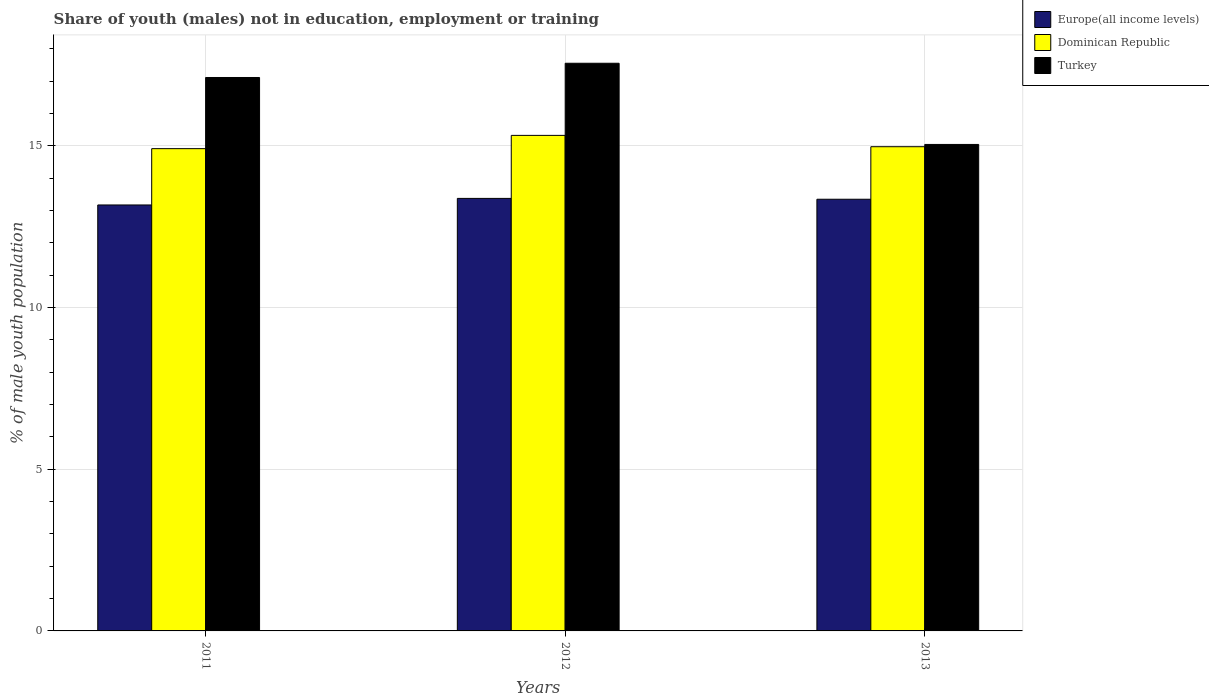Are the number of bars per tick equal to the number of legend labels?
Your answer should be compact. Yes. Are the number of bars on each tick of the X-axis equal?
Keep it short and to the point. Yes. How many bars are there on the 2nd tick from the right?
Offer a very short reply. 3. What is the percentage of unemployed males population in in Turkey in 2011?
Your answer should be compact. 17.11. Across all years, what is the maximum percentage of unemployed males population in in Turkey?
Your response must be concise. 17.55. Across all years, what is the minimum percentage of unemployed males population in in Turkey?
Give a very brief answer. 15.04. What is the total percentage of unemployed males population in in Turkey in the graph?
Ensure brevity in your answer.  49.7. What is the difference between the percentage of unemployed males population in in Dominican Republic in 2011 and that in 2013?
Your answer should be compact. -0.06. What is the difference between the percentage of unemployed males population in in Europe(all income levels) in 2012 and the percentage of unemployed males population in in Dominican Republic in 2013?
Your response must be concise. -1.6. What is the average percentage of unemployed males population in in Turkey per year?
Keep it short and to the point. 16.57. In the year 2013, what is the difference between the percentage of unemployed males population in in Turkey and percentage of unemployed males population in in Europe(all income levels)?
Keep it short and to the point. 1.69. In how many years, is the percentage of unemployed males population in in Dominican Republic greater than 16 %?
Your answer should be very brief. 0. What is the ratio of the percentage of unemployed males population in in Dominican Republic in 2011 to that in 2013?
Offer a terse response. 1. Is the difference between the percentage of unemployed males population in in Turkey in 2011 and 2013 greater than the difference between the percentage of unemployed males population in in Europe(all income levels) in 2011 and 2013?
Your answer should be compact. Yes. What is the difference between the highest and the second highest percentage of unemployed males population in in Europe(all income levels)?
Offer a very short reply. 0.03. What is the difference between the highest and the lowest percentage of unemployed males population in in Europe(all income levels)?
Ensure brevity in your answer.  0.2. What does the 2nd bar from the right in 2011 represents?
Provide a short and direct response. Dominican Republic. How many bars are there?
Keep it short and to the point. 9. How many years are there in the graph?
Offer a terse response. 3. Are the values on the major ticks of Y-axis written in scientific E-notation?
Ensure brevity in your answer.  No. Does the graph contain any zero values?
Your response must be concise. No. Does the graph contain grids?
Offer a terse response. Yes. What is the title of the graph?
Offer a very short reply. Share of youth (males) not in education, employment or training. Does "Other small states" appear as one of the legend labels in the graph?
Give a very brief answer. No. What is the label or title of the Y-axis?
Your answer should be compact. % of male youth population. What is the % of male youth population in Europe(all income levels) in 2011?
Ensure brevity in your answer.  13.17. What is the % of male youth population of Dominican Republic in 2011?
Ensure brevity in your answer.  14.91. What is the % of male youth population of Turkey in 2011?
Your answer should be compact. 17.11. What is the % of male youth population in Europe(all income levels) in 2012?
Ensure brevity in your answer.  13.37. What is the % of male youth population of Dominican Republic in 2012?
Your answer should be very brief. 15.32. What is the % of male youth population of Turkey in 2012?
Provide a succinct answer. 17.55. What is the % of male youth population of Europe(all income levels) in 2013?
Your answer should be compact. 13.35. What is the % of male youth population of Dominican Republic in 2013?
Ensure brevity in your answer.  14.97. What is the % of male youth population in Turkey in 2013?
Give a very brief answer. 15.04. Across all years, what is the maximum % of male youth population of Europe(all income levels)?
Your response must be concise. 13.37. Across all years, what is the maximum % of male youth population in Dominican Republic?
Offer a very short reply. 15.32. Across all years, what is the maximum % of male youth population of Turkey?
Provide a succinct answer. 17.55. Across all years, what is the minimum % of male youth population in Europe(all income levels)?
Provide a short and direct response. 13.17. Across all years, what is the minimum % of male youth population of Dominican Republic?
Keep it short and to the point. 14.91. Across all years, what is the minimum % of male youth population in Turkey?
Your response must be concise. 15.04. What is the total % of male youth population in Europe(all income levels) in the graph?
Your answer should be compact. 39.89. What is the total % of male youth population in Dominican Republic in the graph?
Make the answer very short. 45.2. What is the total % of male youth population in Turkey in the graph?
Offer a very short reply. 49.7. What is the difference between the % of male youth population of Europe(all income levels) in 2011 and that in 2012?
Your answer should be compact. -0.2. What is the difference between the % of male youth population in Dominican Republic in 2011 and that in 2012?
Your answer should be very brief. -0.41. What is the difference between the % of male youth population of Turkey in 2011 and that in 2012?
Give a very brief answer. -0.44. What is the difference between the % of male youth population in Europe(all income levels) in 2011 and that in 2013?
Provide a short and direct response. -0.18. What is the difference between the % of male youth population of Dominican Republic in 2011 and that in 2013?
Give a very brief answer. -0.06. What is the difference between the % of male youth population in Turkey in 2011 and that in 2013?
Give a very brief answer. 2.07. What is the difference between the % of male youth population in Europe(all income levels) in 2012 and that in 2013?
Make the answer very short. 0.03. What is the difference between the % of male youth population of Dominican Republic in 2012 and that in 2013?
Your answer should be compact. 0.35. What is the difference between the % of male youth population in Turkey in 2012 and that in 2013?
Your answer should be very brief. 2.51. What is the difference between the % of male youth population of Europe(all income levels) in 2011 and the % of male youth population of Dominican Republic in 2012?
Provide a short and direct response. -2.15. What is the difference between the % of male youth population of Europe(all income levels) in 2011 and the % of male youth population of Turkey in 2012?
Offer a terse response. -4.38. What is the difference between the % of male youth population in Dominican Republic in 2011 and the % of male youth population in Turkey in 2012?
Offer a very short reply. -2.64. What is the difference between the % of male youth population in Europe(all income levels) in 2011 and the % of male youth population in Dominican Republic in 2013?
Provide a short and direct response. -1.8. What is the difference between the % of male youth population of Europe(all income levels) in 2011 and the % of male youth population of Turkey in 2013?
Make the answer very short. -1.87. What is the difference between the % of male youth population in Dominican Republic in 2011 and the % of male youth population in Turkey in 2013?
Offer a terse response. -0.13. What is the difference between the % of male youth population in Europe(all income levels) in 2012 and the % of male youth population in Dominican Republic in 2013?
Offer a terse response. -1.6. What is the difference between the % of male youth population in Europe(all income levels) in 2012 and the % of male youth population in Turkey in 2013?
Provide a short and direct response. -1.67. What is the difference between the % of male youth population in Dominican Republic in 2012 and the % of male youth population in Turkey in 2013?
Provide a succinct answer. 0.28. What is the average % of male youth population of Europe(all income levels) per year?
Provide a succinct answer. 13.3. What is the average % of male youth population of Dominican Republic per year?
Keep it short and to the point. 15.07. What is the average % of male youth population in Turkey per year?
Ensure brevity in your answer.  16.57. In the year 2011, what is the difference between the % of male youth population of Europe(all income levels) and % of male youth population of Dominican Republic?
Offer a terse response. -1.74. In the year 2011, what is the difference between the % of male youth population of Europe(all income levels) and % of male youth population of Turkey?
Keep it short and to the point. -3.94. In the year 2011, what is the difference between the % of male youth population in Dominican Republic and % of male youth population in Turkey?
Keep it short and to the point. -2.2. In the year 2012, what is the difference between the % of male youth population in Europe(all income levels) and % of male youth population in Dominican Republic?
Provide a short and direct response. -1.95. In the year 2012, what is the difference between the % of male youth population in Europe(all income levels) and % of male youth population in Turkey?
Offer a terse response. -4.18. In the year 2012, what is the difference between the % of male youth population of Dominican Republic and % of male youth population of Turkey?
Your answer should be very brief. -2.23. In the year 2013, what is the difference between the % of male youth population of Europe(all income levels) and % of male youth population of Dominican Republic?
Your answer should be compact. -1.62. In the year 2013, what is the difference between the % of male youth population of Europe(all income levels) and % of male youth population of Turkey?
Offer a very short reply. -1.69. In the year 2013, what is the difference between the % of male youth population in Dominican Republic and % of male youth population in Turkey?
Your answer should be compact. -0.07. What is the ratio of the % of male youth population of Europe(all income levels) in 2011 to that in 2012?
Keep it short and to the point. 0.98. What is the ratio of the % of male youth population of Dominican Republic in 2011 to that in 2012?
Your answer should be compact. 0.97. What is the ratio of the % of male youth population in Turkey in 2011 to that in 2012?
Your response must be concise. 0.97. What is the ratio of the % of male youth population in Dominican Republic in 2011 to that in 2013?
Offer a very short reply. 1. What is the ratio of the % of male youth population in Turkey in 2011 to that in 2013?
Your answer should be compact. 1.14. What is the ratio of the % of male youth population in Dominican Republic in 2012 to that in 2013?
Keep it short and to the point. 1.02. What is the ratio of the % of male youth population in Turkey in 2012 to that in 2013?
Keep it short and to the point. 1.17. What is the difference between the highest and the second highest % of male youth population of Europe(all income levels)?
Ensure brevity in your answer.  0.03. What is the difference between the highest and the second highest % of male youth population in Dominican Republic?
Your answer should be very brief. 0.35. What is the difference between the highest and the second highest % of male youth population of Turkey?
Provide a succinct answer. 0.44. What is the difference between the highest and the lowest % of male youth population of Europe(all income levels)?
Your answer should be compact. 0.2. What is the difference between the highest and the lowest % of male youth population in Dominican Republic?
Ensure brevity in your answer.  0.41. What is the difference between the highest and the lowest % of male youth population of Turkey?
Your response must be concise. 2.51. 